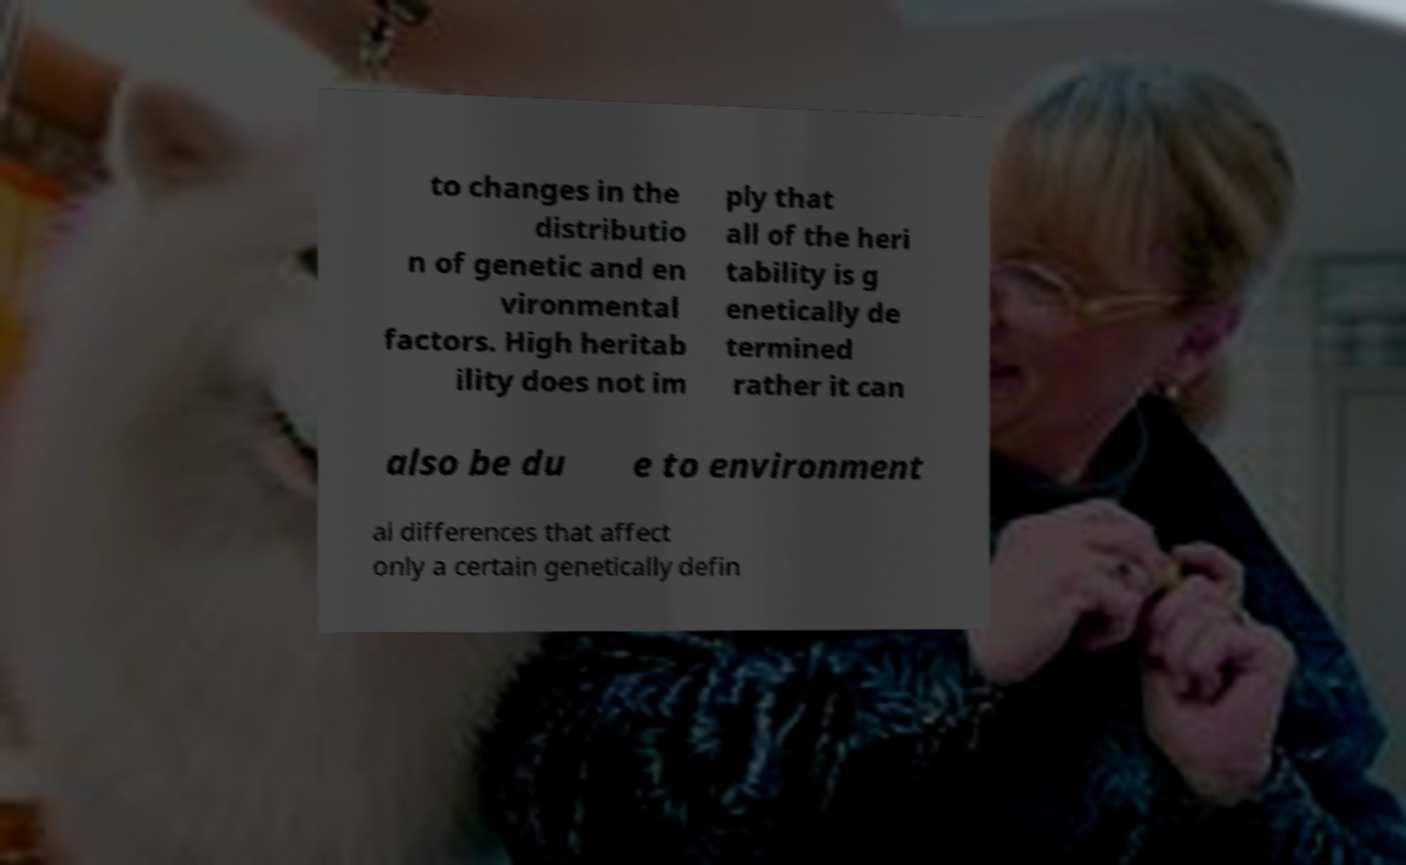There's text embedded in this image that I need extracted. Can you transcribe it verbatim? to changes in the distributio n of genetic and en vironmental factors. High heritab ility does not im ply that all of the heri tability is g enetically de termined rather it can also be du e to environment al differences that affect only a certain genetically defin 